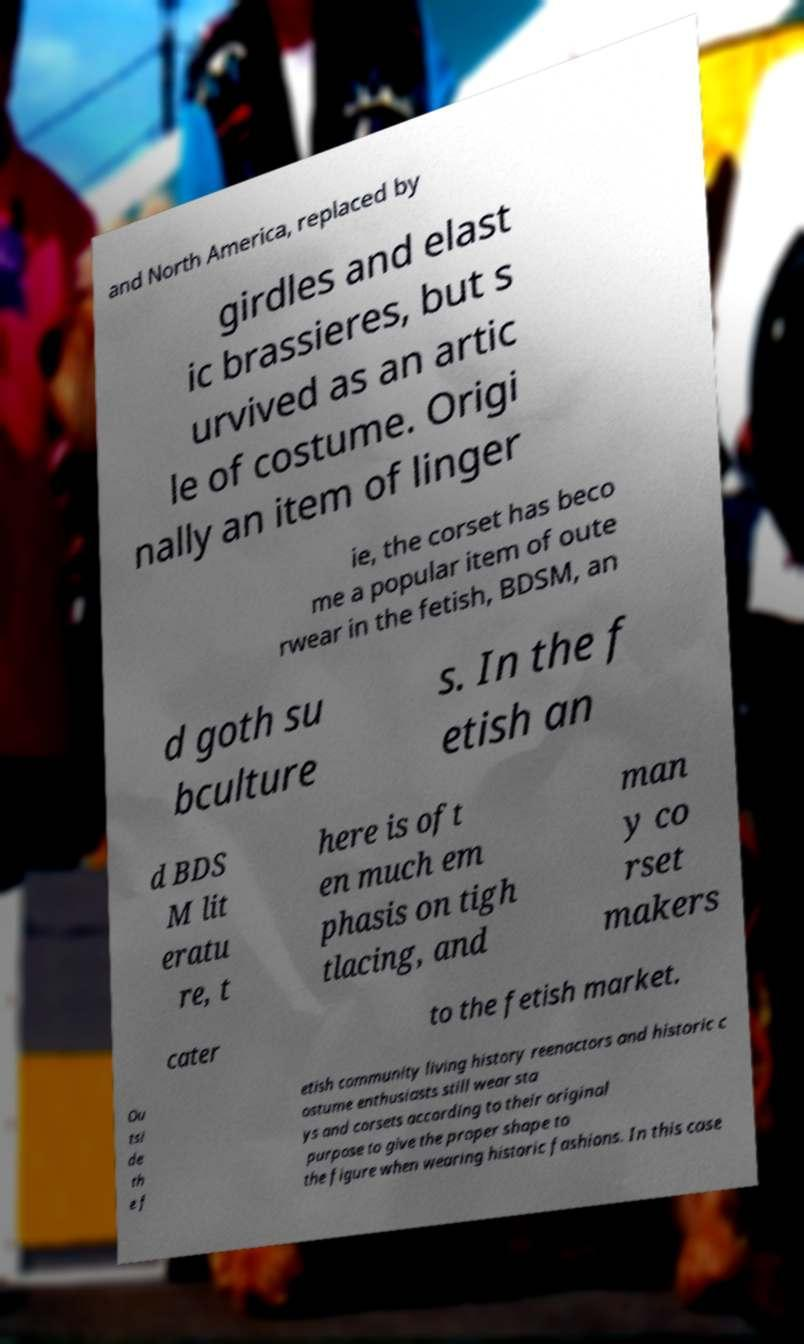Could you assist in decoding the text presented in this image and type it out clearly? and North America, replaced by girdles and elast ic brassieres, but s urvived as an artic le of costume. Origi nally an item of linger ie, the corset has beco me a popular item of oute rwear in the fetish, BDSM, an d goth su bculture s. In the f etish an d BDS M lit eratu re, t here is oft en much em phasis on tigh tlacing, and man y co rset makers cater to the fetish market. Ou tsi de th e f etish community living history reenactors and historic c ostume enthusiasts still wear sta ys and corsets according to their original purpose to give the proper shape to the figure when wearing historic fashions. In this case 